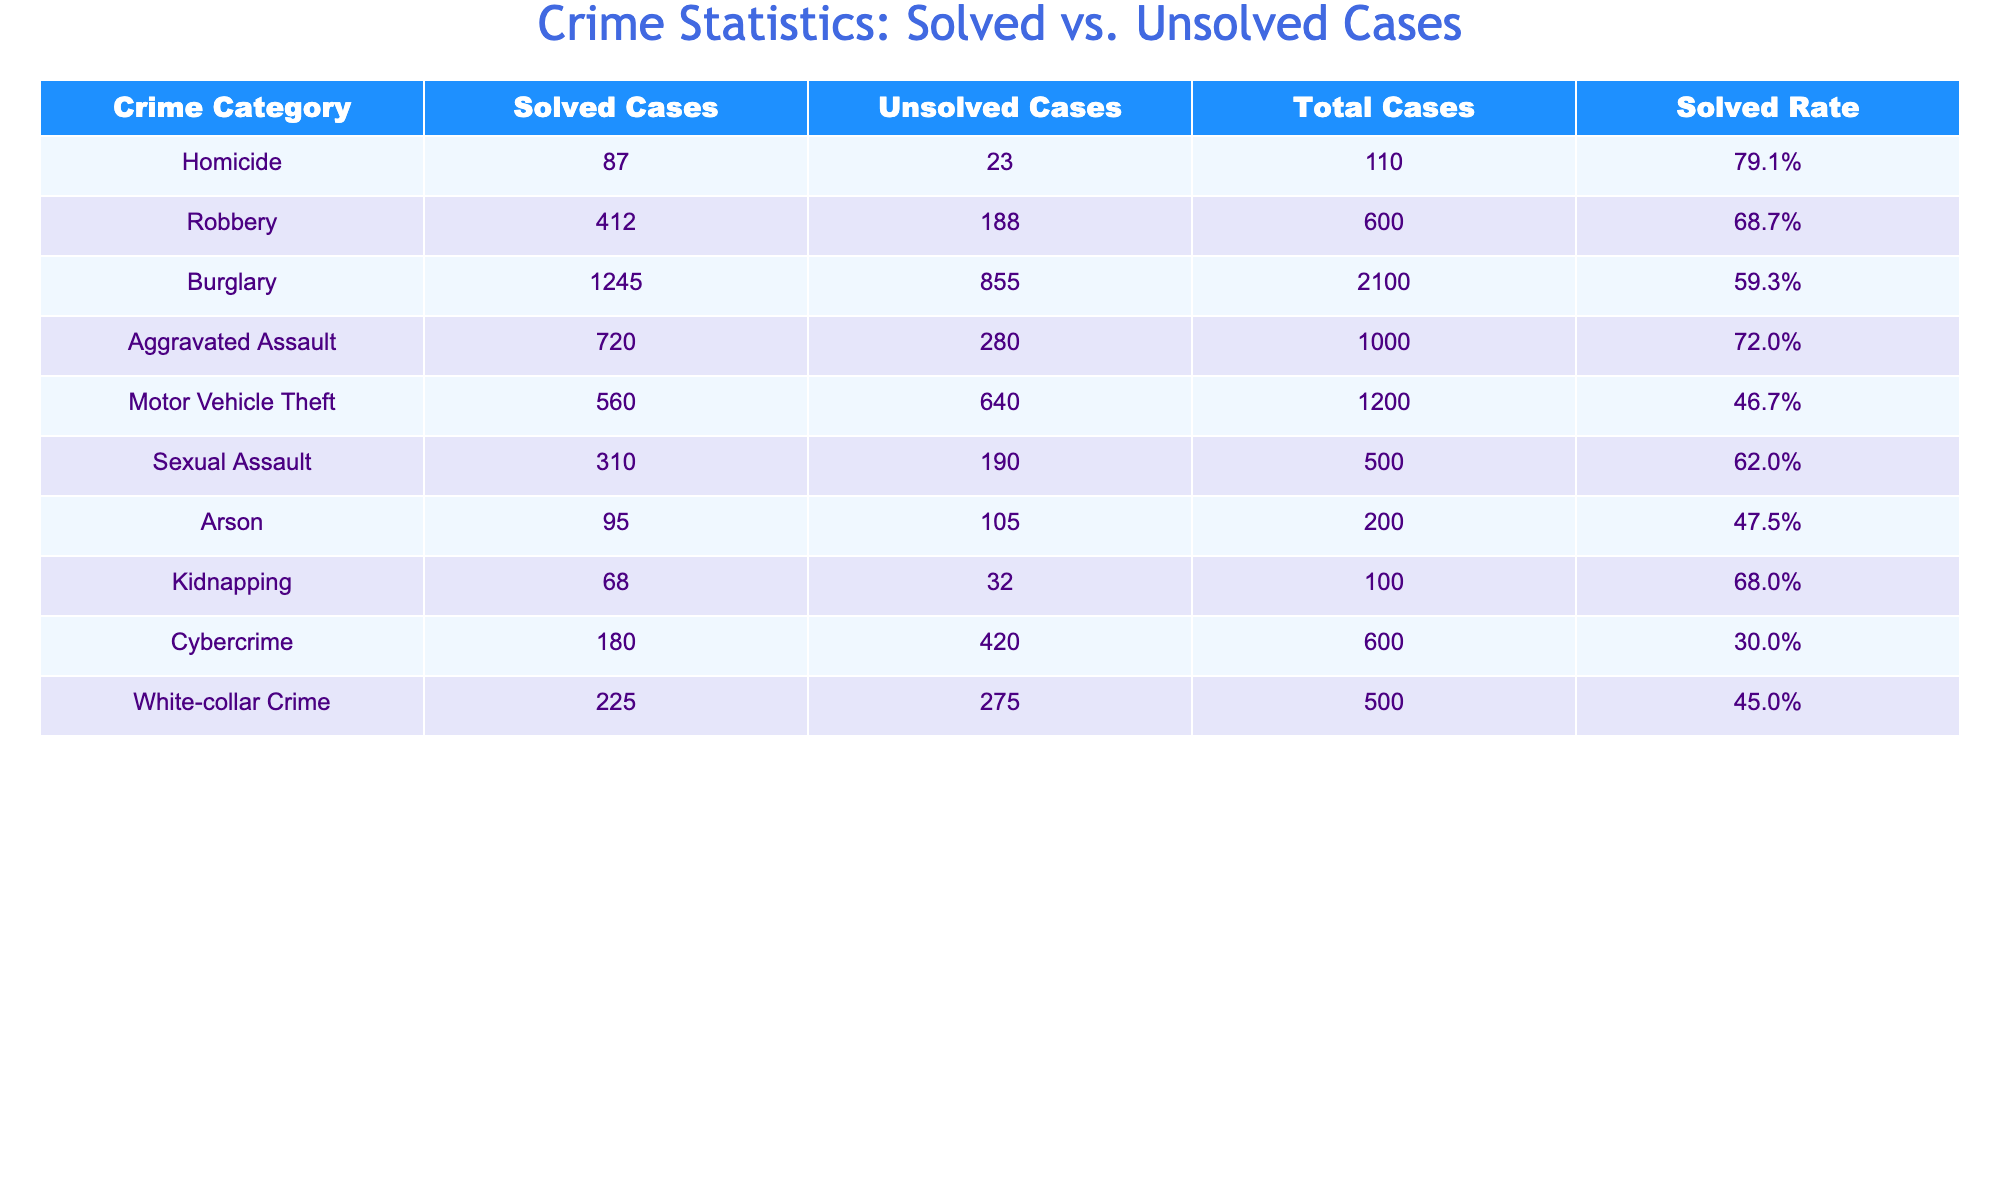What's the total number of homicide cases? The table shows that there are 87 solved and 23 unsolved cases for homicide. The total is calculated by adding solved and unsolved cases: 87 + 23 = 110.
Answer: 110 What is the solved rate for burglary cases? Referring to the table, the solved rate for burglary is explicitly listed as 59.3%.
Answer: 59.3% How many more unsolved cases are there for motor vehicle theft compared to solved cases? The table indicates there are 640 unsolved cases and 560 solved cases. The difference is calculated as follows: 640 - 560 = 80.
Answer: 80 Which crime category has the highest solved cases? The table indicates the solved cases for each category. Homicide has 87, Robbery has 412, Burglary has 1245, Aggravated Assault has 720, Motor Vehicle Theft has 560, Sexual Assault has 310, Arson has 95, Kidnapping has 68, Cybercrime has 180, and White-collar Crime has 225. The highest is 1245 for Burglary.
Answer: Burglary What is the average solved rate of all crime categories? To find the average solved rate, sum the solved rates for each category and divide by the number of categories: (79.1 + 68.7 + 59.3 + 72.0 + 46.7 + 62.0 + 47.5 + 68.0 + 30.0 + 45.0) =  586.3, then divide by 10 (the number of categories): 586.3 / 10 = 58.63%.
Answer: 58.63% Is the solved rate for sexual assault higher than that for motor vehicle theft? The solved rate for Sexual Assault is 62.0% while the solved rate for Motor Vehicle Theft is 46.7%. Since 62.0% > 46.7%, the statement is true.
Answer: Yes What crime category experiences the largest gap between solved and unsolved cases? To determine the largest gap, we subtract the number of solved cases from unsolved cases for each category: Homicide (23 - 87 = -64), Robbery (188 - 412 = -224), Burglary (855 - 1245 = -390), Aggravated Assault (280 - 720 = -440), Motor Vehicle Theft (640 - 560 = 80), Sexual Assault (190 - 310 = -120), Arson (105 - 95 = 10), Kidnapping (32 - 68 = -36), Cybercrime (420 - 180 = 240), and White-collar Crime (275 - 225 = 50). The category with the largest positive gap is Motor Vehicle Theft at 80.
Answer: Motor Vehicle Theft What percent of the total cases in white-collar crime are solved? White-collar Crime shows 225 solved out of a total of 500 cases. To find the percentage, we calculate (225/500)*100 = 45%.
Answer: 45% Which categories have a solved rate below 50%? By comparing the solved rates in the table, both Motor Vehicle Theft (46.7%) and Cybercrime (30.0%) are below 50%.
Answer: Motor Vehicle Theft and Cybercrime If we combine solved cases from robbery and kidnapping, how many total solved cases do we have? From the table, solved cases are 412 for robbery and 68 for kidnapping. Adding them gives: 412 + 68 = 480.
Answer: 480 